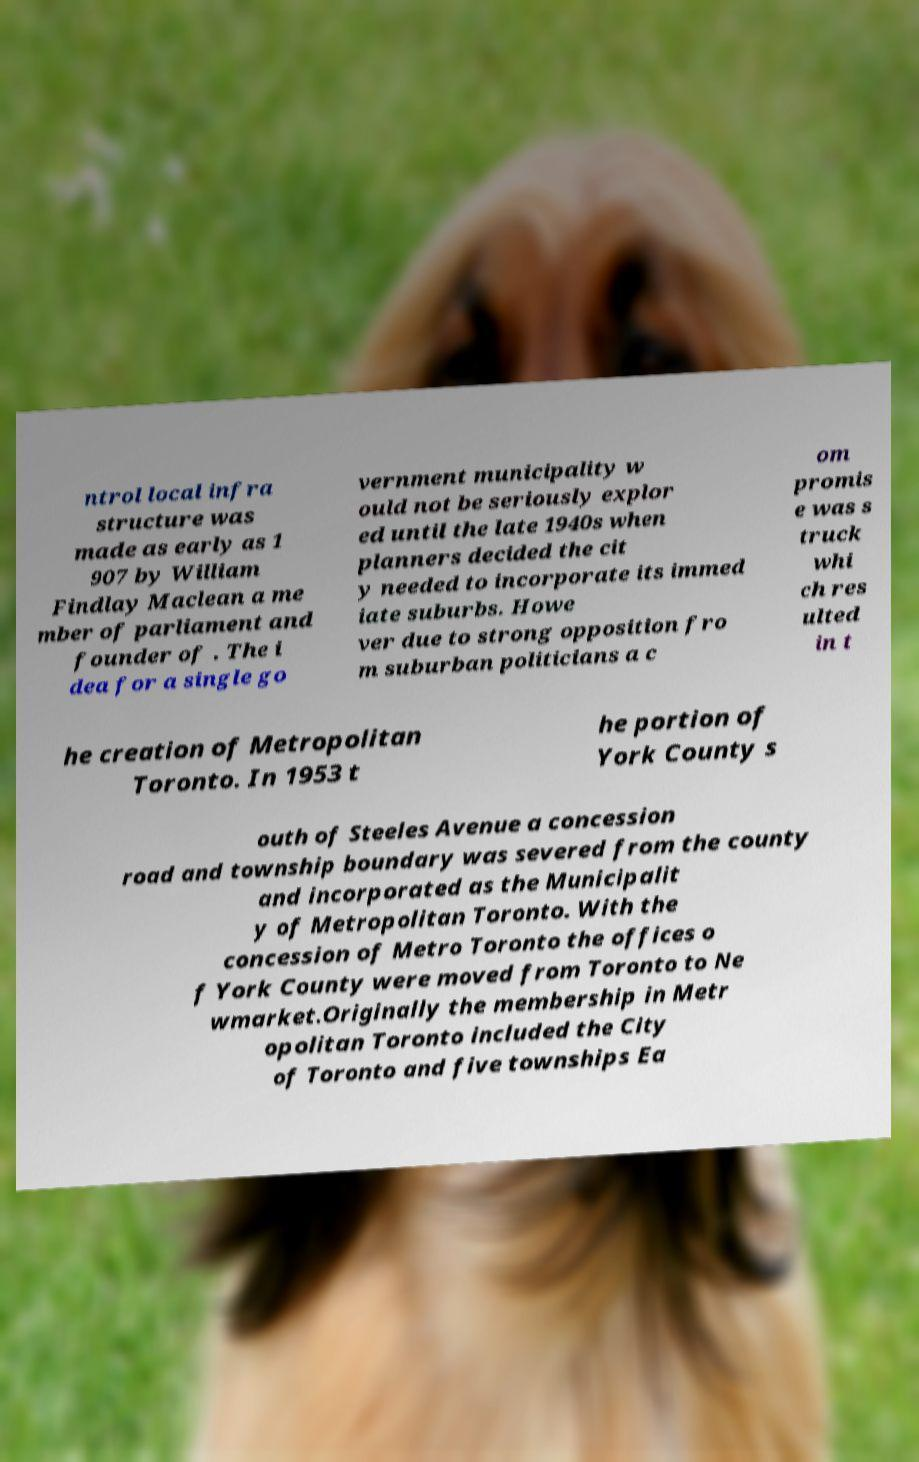What messages or text are displayed in this image? I need them in a readable, typed format. ntrol local infra structure was made as early as 1 907 by William Findlay Maclean a me mber of parliament and founder of . The i dea for a single go vernment municipality w ould not be seriously explor ed until the late 1940s when planners decided the cit y needed to incorporate its immed iate suburbs. Howe ver due to strong opposition fro m suburban politicians a c om promis e was s truck whi ch res ulted in t he creation of Metropolitan Toronto. In 1953 t he portion of York County s outh of Steeles Avenue a concession road and township boundary was severed from the county and incorporated as the Municipalit y of Metropolitan Toronto. With the concession of Metro Toronto the offices o f York County were moved from Toronto to Ne wmarket.Originally the membership in Metr opolitan Toronto included the City of Toronto and five townships Ea 